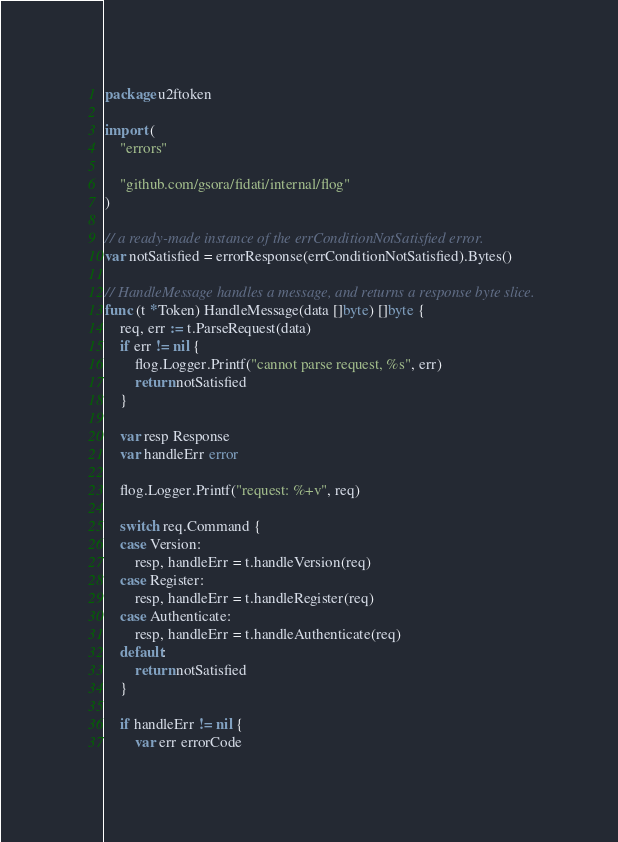Convert code to text. <code><loc_0><loc_0><loc_500><loc_500><_Go_>package u2ftoken

import (
	"errors"

	"github.com/gsora/fidati/internal/flog"
)

// a ready-made instance of the errConditionNotSatisfied error.
var notSatisfied = errorResponse(errConditionNotSatisfied).Bytes()

// HandleMessage handles a message, and returns a response byte slice.
func (t *Token) HandleMessage(data []byte) []byte {
	req, err := t.ParseRequest(data)
	if err != nil {
		flog.Logger.Printf("cannot parse request, %s", err)
		return notSatisfied
	}

	var resp Response
	var handleErr error

	flog.Logger.Printf("request: %+v", req)

	switch req.Command {
	case Version:
		resp, handleErr = t.handleVersion(req)
	case Register:
		resp, handleErr = t.handleRegister(req)
	case Authenticate:
		resp, handleErr = t.handleAuthenticate(req)
	default:
		return notSatisfied
	}

	if handleErr != nil {
		var err errorCode
</code> 